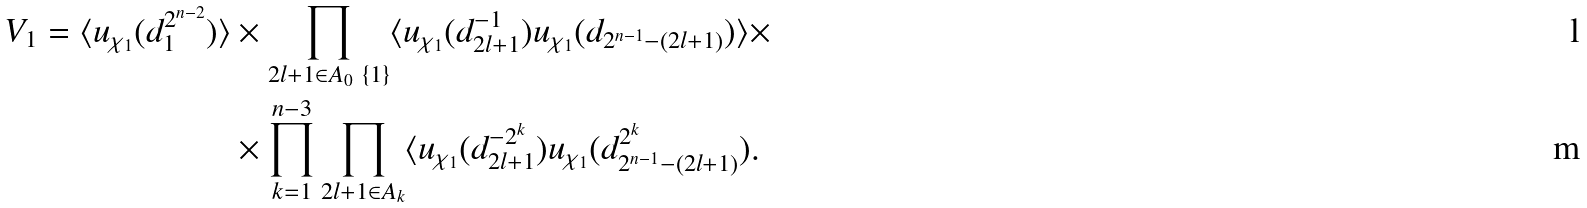Convert formula to latex. <formula><loc_0><loc_0><loc_500><loc_500>V _ { 1 } = \langle u _ { \chi _ { 1 } } ( d _ { 1 } ^ { 2 ^ { n - 2 } } ) \rangle & \times \prod _ { 2 l + 1 \in A _ { 0 } \ \{ 1 \} } \langle u _ { \chi _ { 1 } } ( d _ { 2 l + 1 } ^ { - 1 } ) u _ { \chi _ { 1 } } ( d _ { 2 ^ { n - 1 } - ( 2 l + 1 ) } ) \rangle \times \\ & \times \prod _ { k = 1 } ^ { n - 3 } \prod _ { 2 l + 1 \in A _ { k } } \langle u _ { \chi _ { 1 } } ( d _ { 2 l + 1 } ^ { - 2 ^ { k } } ) u _ { \chi _ { 1 } } ( d _ { 2 ^ { n - 1 } - ( 2 l + 1 ) } ^ { 2 ^ { k } } ) .</formula> 